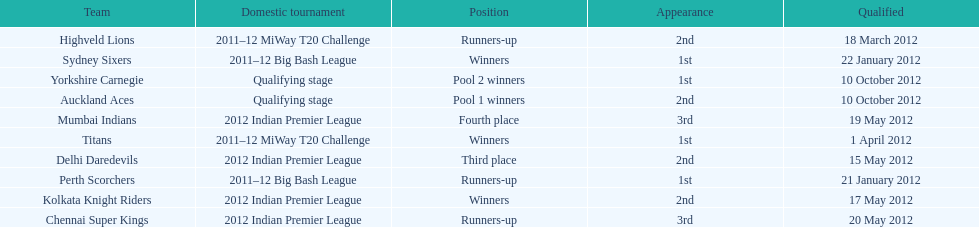Which team came in after the titans in the miway t20 challenge? Highveld Lions. 